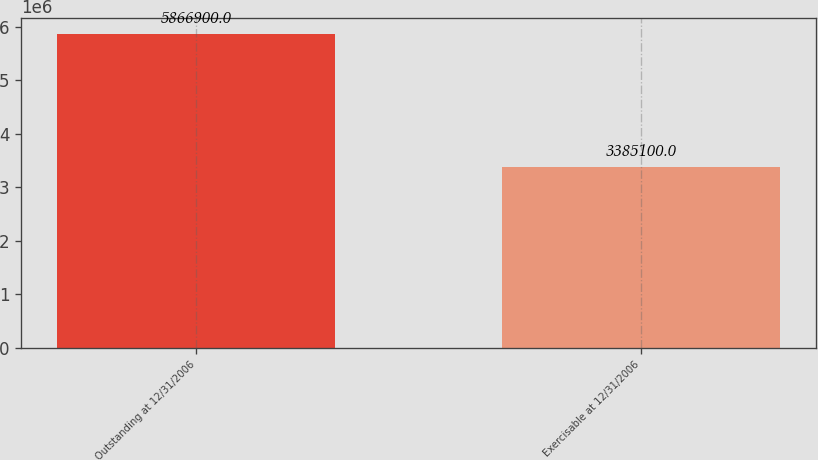Convert chart. <chart><loc_0><loc_0><loc_500><loc_500><bar_chart><fcel>Outstanding at 12/31/2006<fcel>Exercisable at 12/31/2006<nl><fcel>5.8669e+06<fcel>3.3851e+06<nl></chart> 